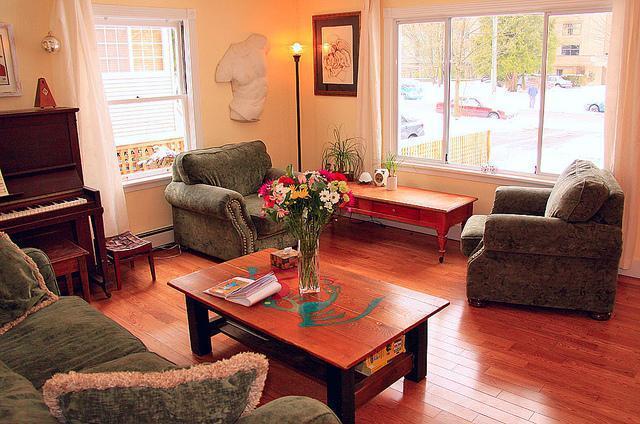How many cars are there?
Give a very brief answer. 5. How many couches are in the photo?
Give a very brief answer. 3. How many chairs are there?
Give a very brief answer. 2. How many zebras are there in the foreground?
Give a very brief answer. 0. 